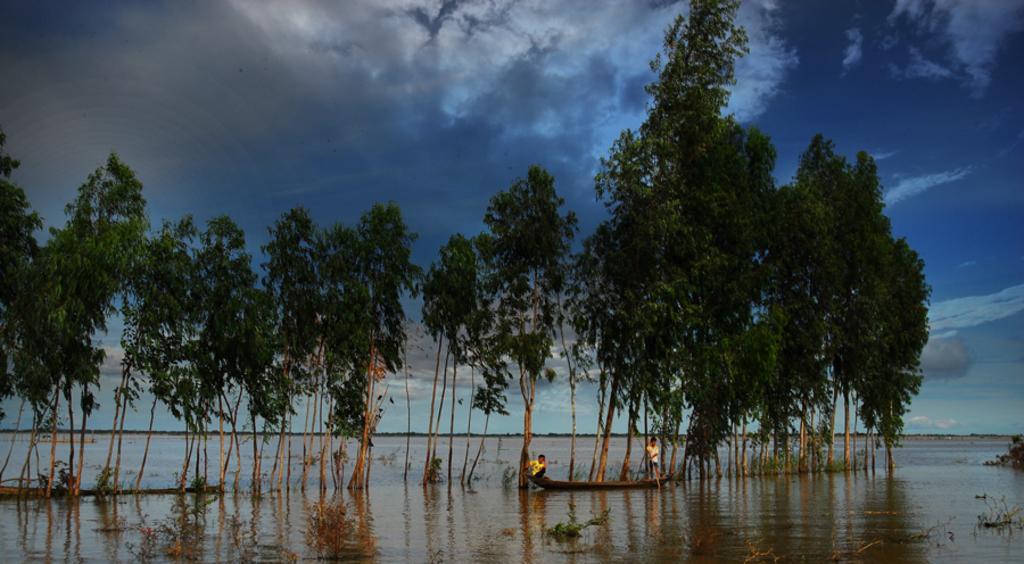How would you summarize this image in a sentence or two? In this image we can see two persons sailing on a boat, on the river, there are some trees, and bushes. 